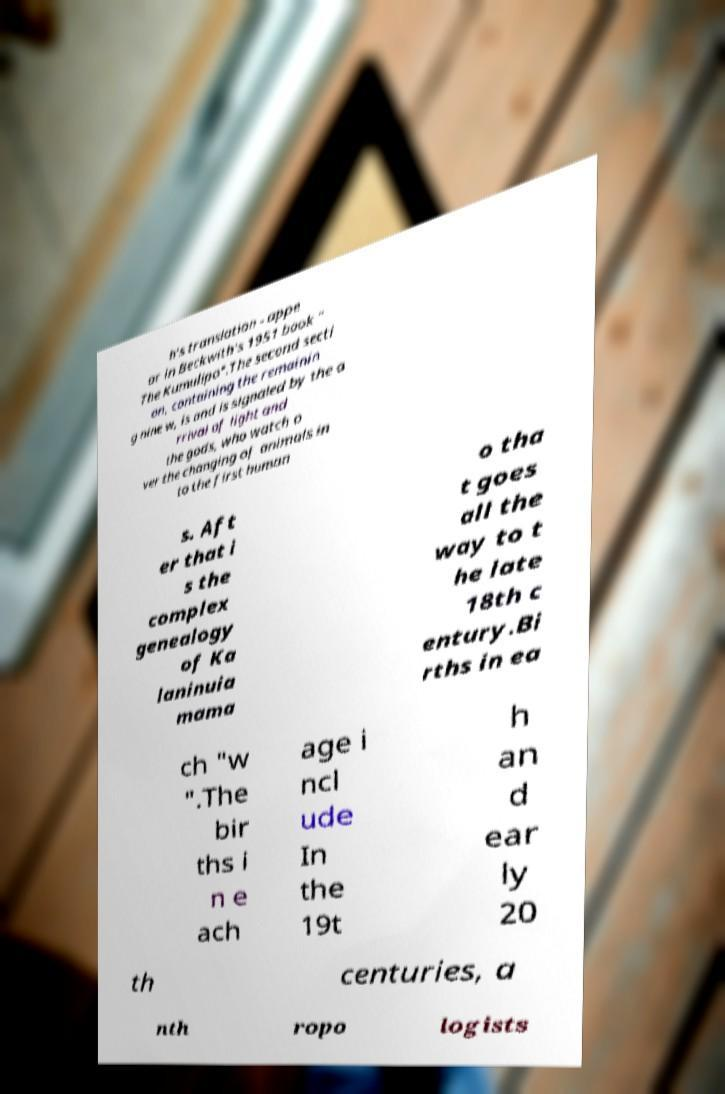Can you accurately transcribe the text from the provided image for me? h's translation - appe ar in Beckwith's 1951 book " The Kumulipo".The second secti on, containing the remainin g nine w, is and is signaled by the a rrival of light and the gods, who watch o ver the changing of animals in to the first human s. Aft er that i s the complex genealogy of Ka laninuia mama o tha t goes all the way to t he late 18th c entury.Bi rths in ea ch "w ".The bir ths i n e ach age i ncl ude In the 19t h an d ear ly 20 th centuries, a nth ropo logists 